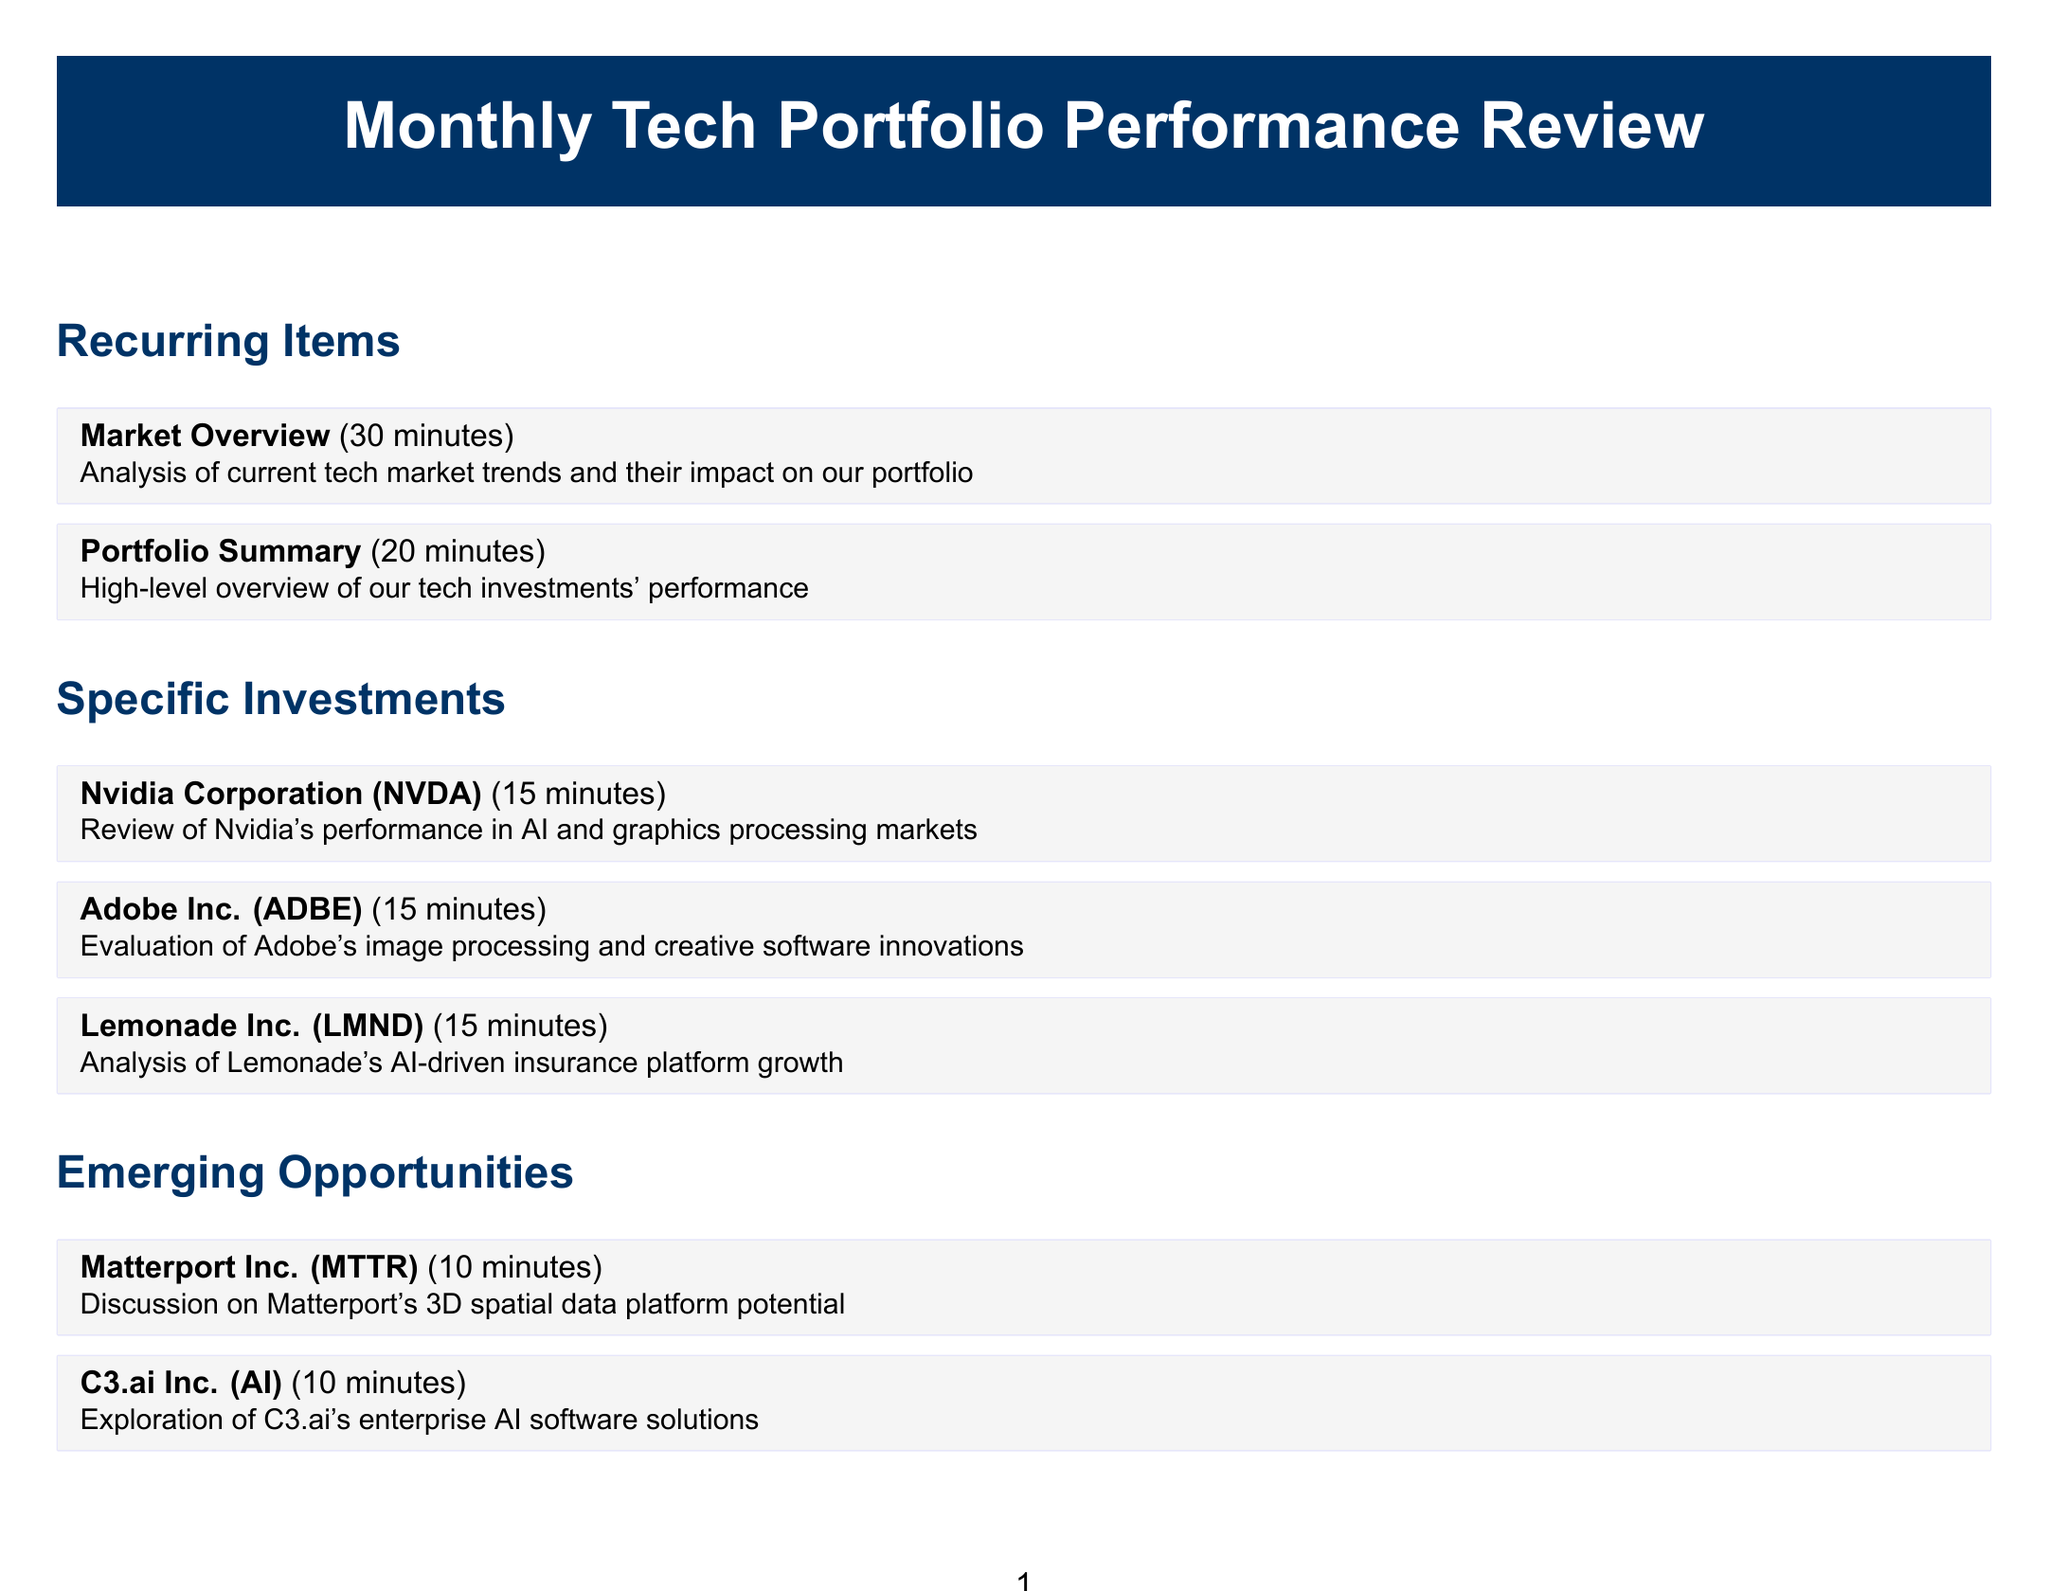What is the duration of the Market Overview? The duration for the Market Overview is specified in the document as 30 minutes.
Answer: 30 minutes How many minutes are allocated for the Adobe Inc. review? Adobe Inc. review is allotted 15 minutes according to the document.
Answer: 15 minutes What is the focus of the Tech Sector Risk Analysis? The focus of the Tech Sector Risk Analysis is on evaluating potential risks affecting tech investments mentioned in the document.
Answer: Potential risks Which company is discussed under emerging opportunities? Matterport Inc. is one of the companies discussed under emerging opportunities in the document.
Answer: Matterport Inc What time is set aside for the Image Processing Algorithm Investment discussion? The discussion is designated a time of 30 minutes in the document.
Answer: 30 minutes How many specific investments are reviewed in total? The document details three specific investments reviewed.
Answer: Three What topic is evaluated in the Portfolio Summary? The Portfolio Summary provides a high-level overview of the tech investments' performance.
Answer: High-level overview How long is the session for Next Steps and Action Items? The duration for Next Steps and Action Items is stated as 15 minutes in the document.
Answer: 15 minutes What do AI and Machine Learning Startups discussions involve? Discussions on AI and Machine Learning Startups involve exploration of promising startups for potential investment.
Answer: Exploration of promising startups 